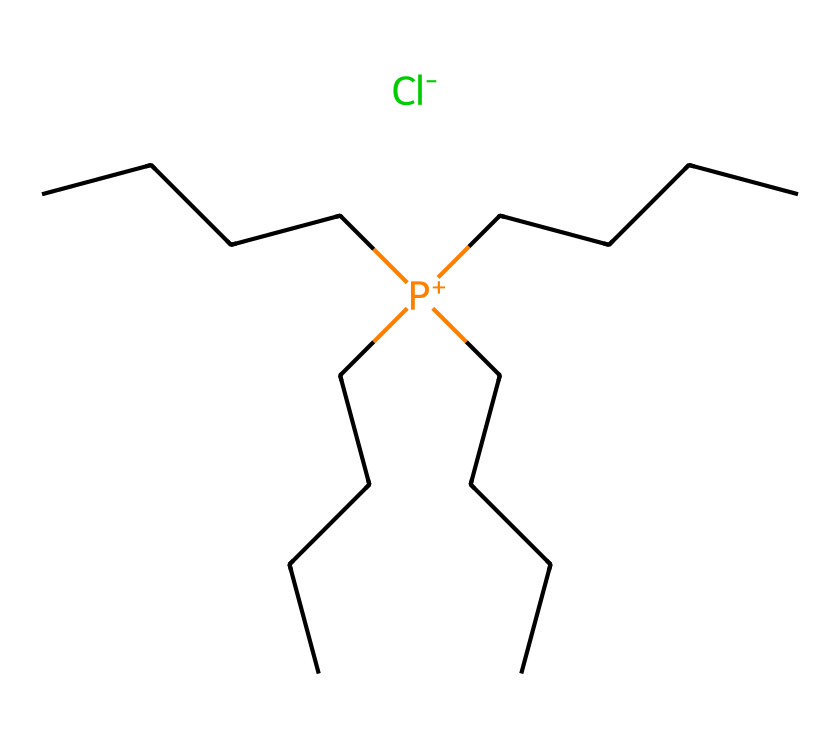how many carbon atoms are present in this ionic liquid? Counting the carbon atoms in the provided SMILES representation, there are four linear carbon chains with 4 carbon atoms each (CCCC), resulting in a total of 16 carbon atoms when combined with the central phosphorus atom.
Answer: 16 what is the charge of the phosphonium ion in this ionic liquid? The representation indicates a positively charged phosphonium ion ([P+]), which is denoted by the presence of a plus sign next to the phosphorus atom.
Answer: +1 what type of anion is associated with this phosphonium ionic liquid? The SMILES representation shows a chloride ion ([Cl-]), indicated by the presence of the negative sign next to the chloride atom.
Answer: chloride how does the length of carbon chains influence the solubility of this ionic liquid? The length of the carbon chains in the ionic liquid affects its hydrophobic characteristics, meaning longer chains typically result in lower solubility in polar solvents due to increased hydrophobic interactions.
Answer: longer chains reduce solubility what potential applications can this phosphonium ionic liquid have in tissue engineering? Given its structural characteristics, including biocompatibility and ionic nature, this phosphonium ionic liquid could be utilized for designing scaffolds that promote cell growth and tissue regeneration.
Answer: tissue scaffolds what is the significance of the phosphonium group in this ionic liquid? The phosphonium group contributes to the ionic nature of the liquid, which helps in forming stable ionic networks that can enhance properties like conductivity and biocompatibility, essential for biomedical applications.
Answer: enhances biocompatibility 